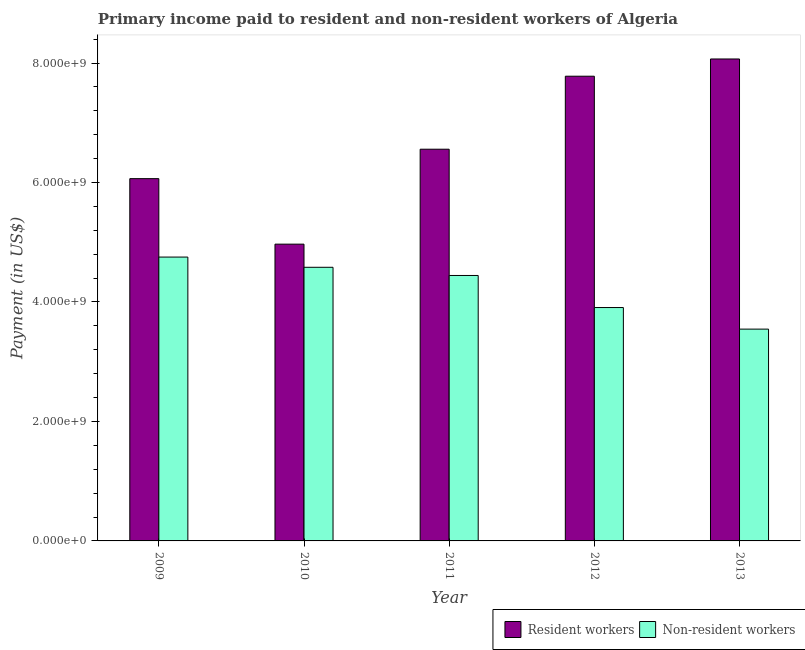How many different coloured bars are there?
Make the answer very short. 2. How many groups of bars are there?
Make the answer very short. 5. Are the number of bars per tick equal to the number of legend labels?
Offer a very short reply. Yes. Are the number of bars on each tick of the X-axis equal?
Ensure brevity in your answer.  Yes. How many bars are there on the 4th tick from the left?
Ensure brevity in your answer.  2. In how many cases, is the number of bars for a given year not equal to the number of legend labels?
Your answer should be compact. 0. What is the payment made to non-resident workers in 2011?
Your answer should be very brief. 4.44e+09. Across all years, what is the maximum payment made to non-resident workers?
Your answer should be very brief. 4.75e+09. Across all years, what is the minimum payment made to non-resident workers?
Your answer should be very brief. 3.55e+09. What is the total payment made to non-resident workers in the graph?
Offer a terse response. 2.12e+1. What is the difference between the payment made to resident workers in 2009 and that in 2013?
Your answer should be compact. -2.00e+09. What is the difference between the payment made to resident workers in 2012 and the payment made to non-resident workers in 2009?
Your answer should be very brief. 1.71e+09. What is the average payment made to resident workers per year?
Your response must be concise. 6.69e+09. In the year 2011, what is the difference between the payment made to non-resident workers and payment made to resident workers?
Your answer should be compact. 0. In how many years, is the payment made to resident workers greater than 4000000000 US$?
Your response must be concise. 5. What is the ratio of the payment made to non-resident workers in 2011 to that in 2013?
Give a very brief answer. 1.25. Is the payment made to resident workers in 2009 less than that in 2010?
Your response must be concise. No. Is the difference between the payment made to resident workers in 2009 and 2013 greater than the difference between the payment made to non-resident workers in 2009 and 2013?
Ensure brevity in your answer.  No. What is the difference between the highest and the second highest payment made to resident workers?
Ensure brevity in your answer.  2.89e+08. What is the difference between the highest and the lowest payment made to resident workers?
Give a very brief answer. 3.10e+09. In how many years, is the payment made to resident workers greater than the average payment made to resident workers taken over all years?
Provide a short and direct response. 2. Is the sum of the payment made to non-resident workers in 2012 and 2013 greater than the maximum payment made to resident workers across all years?
Provide a succinct answer. Yes. What does the 1st bar from the left in 2009 represents?
Give a very brief answer. Resident workers. What does the 2nd bar from the right in 2011 represents?
Your answer should be very brief. Resident workers. Are all the bars in the graph horizontal?
Offer a very short reply. No. How many years are there in the graph?
Your answer should be very brief. 5. Does the graph contain any zero values?
Provide a short and direct response. No. Where does the legend appear in the graph?
Give a very brief answer. Bottom right. How many legend labels are there?
Your answer should be very brief. 2. How are the legend labels stacked?
Make the answer very short. Horizontal. What is the title of the graph?
Provide a succinct answer. Primary income paid to resident and non-resident workers of Algeria. What is the label or title of the Y-axis?
Your answer should be compact. Payment (in US$). What is the Payment (in US$) in Resident workers in 2009?
Provide a succinct answer. 6.06e+09. What is the Payment (in US$) in Non-resident workers in 2009?
Your answer should be very brief. 4.75e+09. What is the Payment (in US$) in Resident workers in 2010?
Your answer should be compact. 4.97e+09. What is the Payment (in US$) of Non-resident workers in 2010?
Keep it short and to the point. 4.58e+09. What is the Payment (in US$) in Resident workers in 2011?
Offer a very short reply. 6.56e+09. What is the Payment (in US$) in Non-resident workers in 2011?
Provide a succinct answer. 4.44e+09. What is the Payment (in US$) in Resident workers in 2012?
Offer a terse response. 7.78e+09. What is the Payment (in US$) in Non-resident workers in 2012?
Offer a very short reply. 3.91e+09. What is the Payment (in US$) of Resident workers in 2013?
Give a very brief answer. 8.07e+09. What is the Payment (in US$) in Non-resident workers in 2013?
Give a very brief answer. 3.55e+09. Across all years, what is the maximum Payment (in US$) in Resident workers?
Your answer should be compact. 8.07e+09. Across all years, what is the maximum Payment (in US$) of Non-resident workers?
Keep it short and to the point. 4.75e+09. Across all years, what is the minimum Payment (in US$) of Resident workers?
Ensure brevity in your answer.  4.97e+09. Across all years, what is the minimum Payment (in US$) of Non-resident workers?
Your answer should be very brief. 3.55e+09. What is the total Payment (in US$) of Resident workers in the graph?
Provide a succinct answer. 3.34e+1. What is the total Payment (in US$) of Non-resident workers in the graph?
Your answer should be very brief. 2.12e+1. What is the difference between the Payment (in US$) of Resident workers in 2009 and that in 2010?
Provide a short and direct response. 1.10e+09. What is the difference between the Payment (in US$) in Non-resident workers in 2009 and that in 2010?
Provide a succinct answer. 1.71e+08. What is the difference between the Payment (in US$) in Resident workers in 2009 and that in 2011?
Your response must be concise. -4.93e+08. What is the difference between the Payment (in US$) in Non-resident workers in 2009 and that in 2011?
Give a very brief answer. 3.08e+08. What is the difference between the Payment (in US$) of Resident workers in 2009 and that in 2012?
Offer a very short reply. -1.71e+09. What is the difference between the Payment (in US$) of Non-resident workers in 2009 and that in 2012?
Provide a succinct answer. 8.45e+08. What is the difference between the Payment (in US$) in Resident workers in 2009 and that in 2013?
Provide a short and direct response. -2.00e+09. What is the difference between the Payment (in US$) of Non-resident workers in 2009 and that in 2013?
Provide a short and direct response. 1.21e+09. What is the difference between the Payment (in US$) in Resident workers in 2010 and that in 2011?
Offer a terse response. -1.59e+09. What is the difference between the Payment (in US$) of Non-resident workers in 2010 and that in 2011?
Ensure brevity in your answer.  1.37e+08. What is the difference between the Payment (in US$) in Resident workers in 2010 and that in 2012?
Provide a short and direct response. -2.81e+09. What is the difference between the Payment (in US$) in Non-resident workers in 2010 and that in 2012?
Your answer should be compact. 6.74e+08. What is the difference between the Payment (in US$) in Resident workers in 2010 and that in 2013?
Provide a short and direct response. -3.10e+09. What is the difference between the Payment (in US$) in Non-resident workers in 2010 and that in 2013?
Your answer should be compact. 1.03e+09. What is the difference between the Payment (in US$) of Resident workers in 2011 and that in 2012?
Ensure brevity in your answer.  -1.22e+09. What is the difference between the Payment (in US$) in Non-resident workers in 2011 and that in 2012?
Offer a terse response. 5.37e+08. What is the difference between the Payment (in US$) of Resident workers in 2011 and that in 2013?
Your response must be concise. -1.51e+09. What is the difference between the Payment (in US$) of Non-resident workers in 2011 and that in 2013?
Provide a succinct answer. 8.98e+08. What is the difference between the Payment (in US$) in Resident workers in 2012 and that in 2013?
Offer a very short reply. -2.89e+08. What is the difference between the Payment (in US$) of Non-resident workers in 2012 and that in 2013?
Your answer should be compact. 3.61e+08. What is the difference between the Payment (in US$) of Resident workers in 2009 and the Payment (in US$) of Non-resident workers in 2010?
Your answer should be very brief. 1.48e+09. What is the difference between the Payment (in US$) of Resident workers in 2009 and the Payment (in US$) of Non-resident workers in 2011?
Your answer should be very brief. 1.62e+09. What is the difference between the Payment (in US$) of Resident workers in 2009 and the Payment (in US$) of Non-resident workers in 2012?
Your answer should be very brief. 2.16e+09. What is the difference between the Payment (in US$) of Resident workers in 2009 and the Payment (in US$) of Non-resident workers in 2013?
Provide a short and direct response. 2.52e+09. What is the difference between the Payment (in US$) in Resident workers in 2010 and the Payment (in US$) in Non-resident workers in 2011?
Make the answer very short. 5.25e+08. What is the difference between the Payment (in US$) in Resident workers in 2010 and the Payment (in US$) in Non-resident workers in 2012?
Give a very brief answer. 1.06e+09. What is the difference between the Payment (in US$) of Resident workers in 2010 and the Payment (in US$) of Non-resident workers in 2013?
Offer a terse response. 1.42e+09. What is the difference between the Payment (in US$) in Resident workers in 2011 and the Payment (in US$) in Non-resident workers in 2012?
Your answer should be very brief. 2.65e+09. What is the difference between the Payment (in US$) of Resident workers in 2011 and the Payment (in US$) of Non-resident workers in 2013?
Your answer should be very brief. 3.01e+09. What is the difference between the Payment (in US$) in Resident workers in 2012 and the Payment (in US$) in Non-resident workers in 2013?
Your answer should be compact. 4.23e+09. What is the average Payment (in US$) in Resident workers per year?
Your answer should be compact. 6.69e+09. What is the average Payment (in US$) of Non-resident workers per year?
Keep it short and to the point. 4.25e+09. In the year 2009, what is the difference between the Payment (in US$) of Resident workers and Payment (in US$) of Non-resident workers?
Keep it short and to the point. 1.31e+09. In the year 2010, what is the difference between the Payment (in US$) of Resident workers and Payment (in US$) of Non-resident workers?
Your answer should be very brief. 3.87e+08. In the year 2011, what is the difference between the Payment (in US$) in Resident workers and Payment (in US$) in Non-resident workers?
Your answer should be very brief. 2.11e+09. In the year 2012, what is the difference between the Payment (in US$) of Resident workers and Payment (in US$) of Non-resident workers?
Ensure brevity in your answer.  3.87e+09. In the year 2013, what is the difference between the Payment (in US$) in Resident workers and Payment (in US$) in Non-resident workers?
Offer a very short reply. 4.52e+09. What is the ratio of the Payment (in US$) of Resident workers in 2009 to that in 2010?
Keep it short and to the point. 1.22. What is the ratio of the Payment (in US$) of Non-resident workers in 2009 to that in 2010?
Your answer should be very brief. 1.04. What is the ratio of the Payment (in US$) of Resident workers in 2009 to that in 2011?
Your response must be concise. 0.92. What is the ratio of the Payment (in US$) in Non-resident workers in 2009 to that in 2011?
Keep it short and to the point. 1.07. What is the ratio of the Payment (in US$) of Resident workers in 2009 to that in 2012?
Make the answer very short. 0.78. What is the ratio of the Payment (in US$) of Non-resident workers in 2009 to that in 2012?
Make the answer very short. 1.22. What is the ratio of the Payment (in US$) in Resident workers in 2009 to that in 2013?
Provide a short and direct response. 0.75. What is the ratio of the Payment (in US$) in Non-resident workers in 2009 to that in 2013?
Offer a terse response. 1.34. What is the ratio of the Payment (in US$) of Resident workers in 2010 to that in 2011?
Your answer should be compact. 0.76. What is the ratio of the Payment (in US$) in Non-resident workers in 2010 to that in 2011?
Keep it short and to the point. 1.03. What is the ratio of the Payment (in US$) in Resident workers in 2010 to that in 2012?
Offer a very short reply. 0.64. What is the ratio of the Payment (in US$) of Non-resident workers in 2010 to that in 2012?
Make the answer very short. 1.17. What is the ratio of the Payment (in US$) in Resident workers in 2010 to that in 2013?
Make the answer very short. 0.62. What is the ratio of the Payment (in US$) in Non-resident workers in 2010 to that in 2013?
Your answer should be very brief. 1.29. What is the ratio of the Payment (in US$) of Resident workers in 2011 to that in 2012?
Your answer should be compact. 0.84. What is the ratio of the Payment (in US$) of Non-resident workers in 2011 to that in 2012?
Offer a very short reply. 1.14. What is the ratio of the Payment (in US$) of Resident workers in 2011 to that in 2013?
Your answer should be compact. 0.81. What is the ratio of the Payment (in US$) of Non-resident workers in 2011 to that in 2013?
Provide a short and direct response. 1.25. What is the ratio of the Payment (in US$) of Resident workers in 2012 to that in 2013?
Your answer should be compact. 0.96. What is the ratio of the Payment (in US$) in Non-resident workers in 2012 to that in 2013?
Keep it short and to the point. 1.1. What is the difference between the highest and the second highest Payment (in US$) of Resident workers?
Your answer should be very brief. 2.89e+08. What is the difference between the highest and the second highest Payment (in US$) of Non-resident workers?
Make the answer very short. 1.71e+08. What is the difference between the highest and the lowest Payment (in US$) in Resident workers?
Ensure brevity in your answer.  3.10e+09. What is the difference between the highest and the lowest Payment (in US$) in Non-resident workers?
Give a very brief answer. 1.21e+09. 